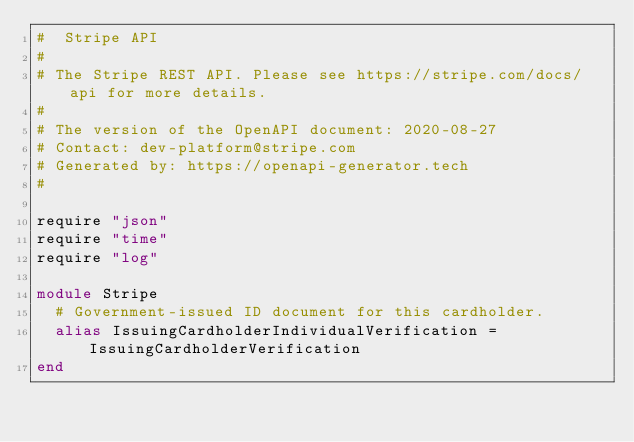Convert code to text. <code><loc_0><loc_0><loc_500><loc_500><_Crystal_>#  Stripe API
#
# The Stripe REST API. Please see https://stripe.com/docs/api for more details.
#
# The version of the OpenAPI document: 2020-08-27
# Contact: dev-platform@stripe.com
# Generated by: https://openapi-generator.tech
#

require "json"
require "time"
require "log"

module Stripe
  # Government-issued ID document for this cardholder.
  alias IssuingCardholderIndividualVerification = IssuingCardholderVerification
end
</code> 